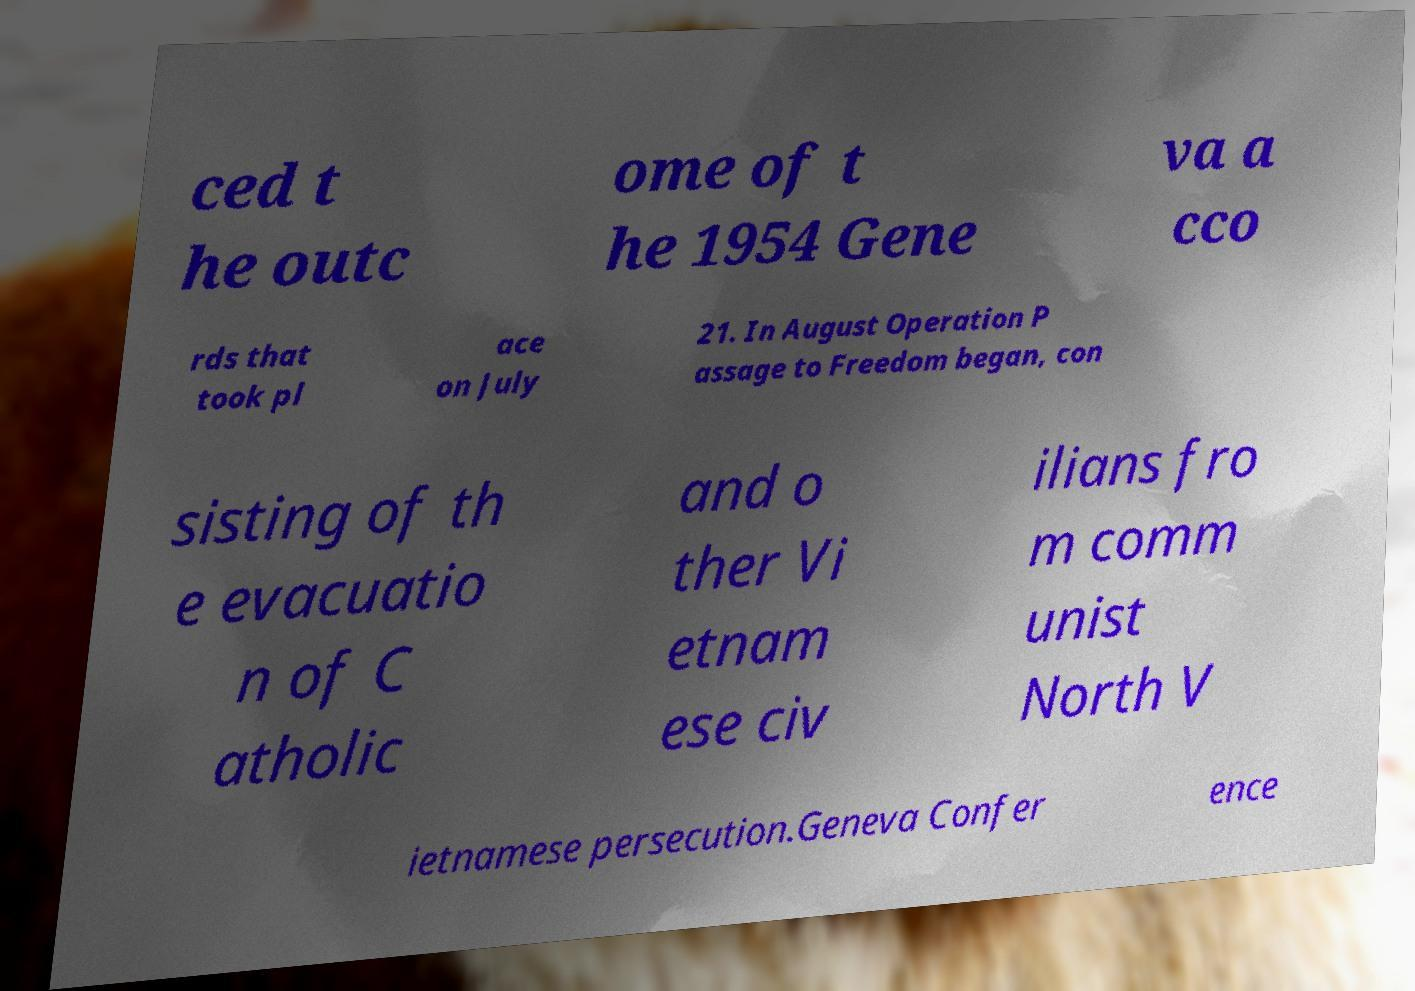What messages or text are displayed in this image? I need them in a readable, typed format. ced t he outc ome of t he 1954 Gene va a cco rds that took pl ace on July 21. In August Operation P assage to Freedom began, con sisting of th e evacuatio n of C atholic and o ther Vi etnam ese civ ilians fro m comm unist North V ietnamese persecution.Geneva Confer ence 